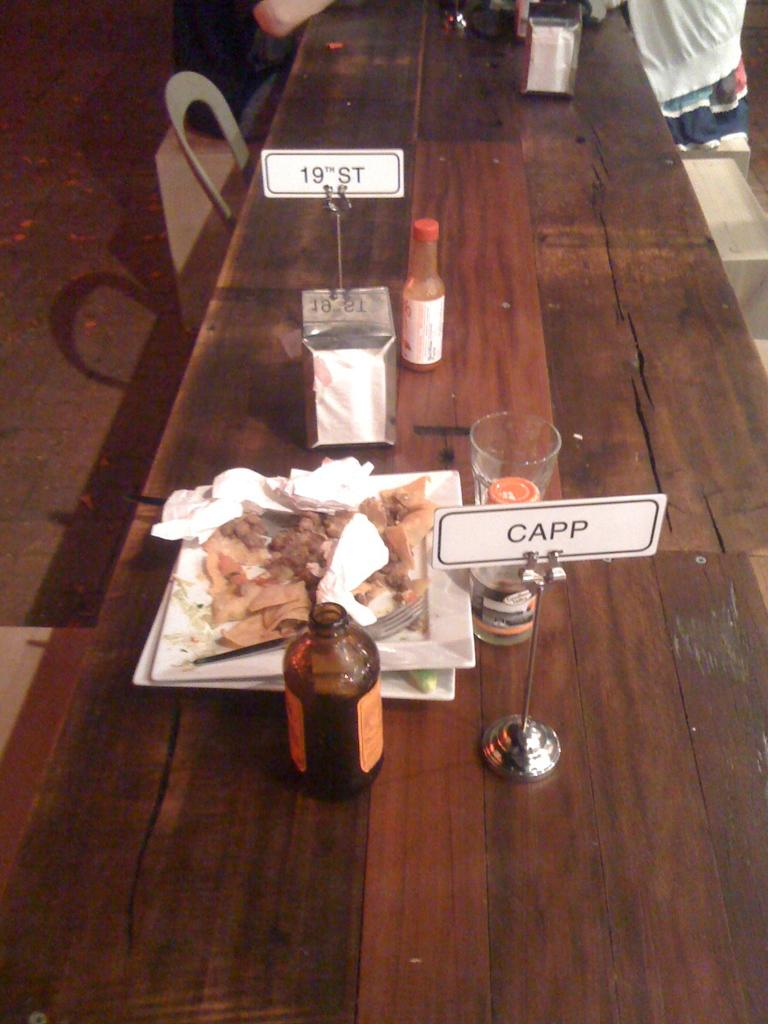Provide a one-sentence caption for the provided image. A little sign on a table says "CAPP" and is sitting next to a messy plate of food. 